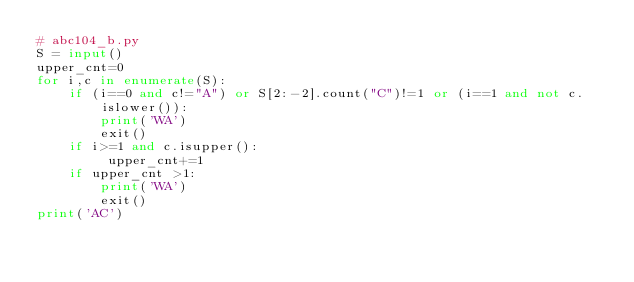<code> <loc_0><loc_0><loc_500><loc_500><_Python_># abc104_b.py
S = input()
upper_cnt=0
for i,c in enumerate(S):
    if (i==0 and c!="A") or S[2:-2].count("C")!=1 or (i==1 and not c.islower()):
        print('WA')
        exit()
    if i>=1 and c.isupper():
         upper_cnt+=1
    if upper_cnt >1:
        print('WA')
        exit()
print('AC')</code> 